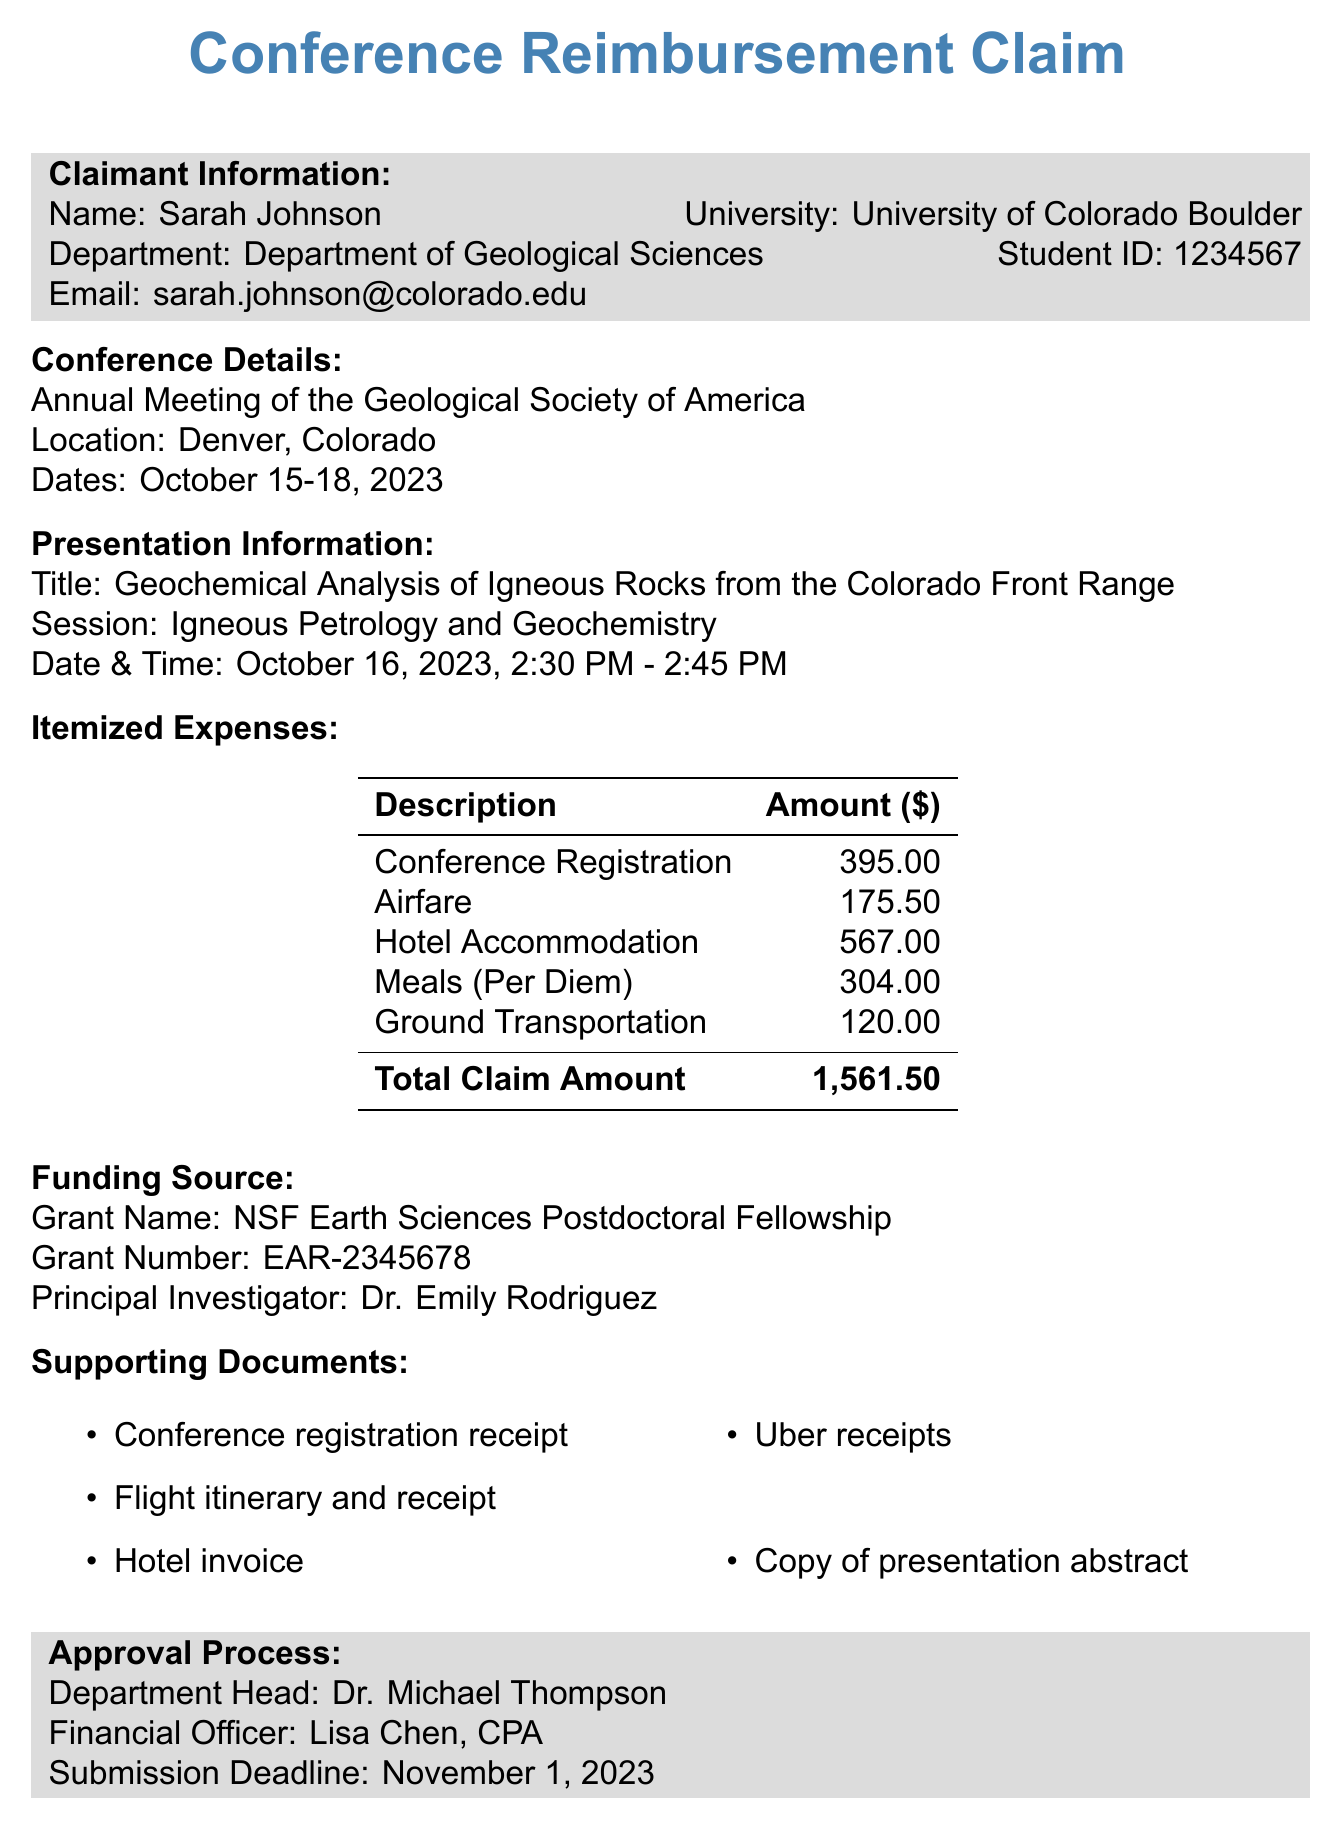What is the name of the claimant? The name of the claimant is mentioned in the document as Sarah Johnson.
Answer: Sarah Johnson What is the registration fee for the conference? The document specifies the registration fee for the conference as $395.00.
Answer: $395.00 What is the total claim amount? The total claim amount is calculated as the sum of all itemized expenses in the document, which is $1561.50.
Answer: $1,561.50 What is the title of the presentation? The title of the presentation conducted by the claimant is provided as "Geochemical Analysis of Igneous Rocks from the Colorado Front Range."
Answer: Geochemical Analysis of Igneous Rocks from the Colorado Front Range When is the submission deadline for the reimbursement claim? The submission deadline is explicitly stated in the document as November 1, 2023.
Answer: November 1, 2023 How many nights did the claimant stay at the hotel? The document indicates that the claimant stayed at the hotel for a total of 3 nights.
Answer: 3 nights Which grant funds the expenses? The grant funding the expenses is referred to in the document as "NSF Earth Sciences Postdoctoral Fellowship."
Answer: NSF Earth Sciences Postdoctoral Fellowship What mode of transportation did the claimant use to travel? The mode of transportation utilized for travel is provided in the document as Flight.
Answer: Flight 